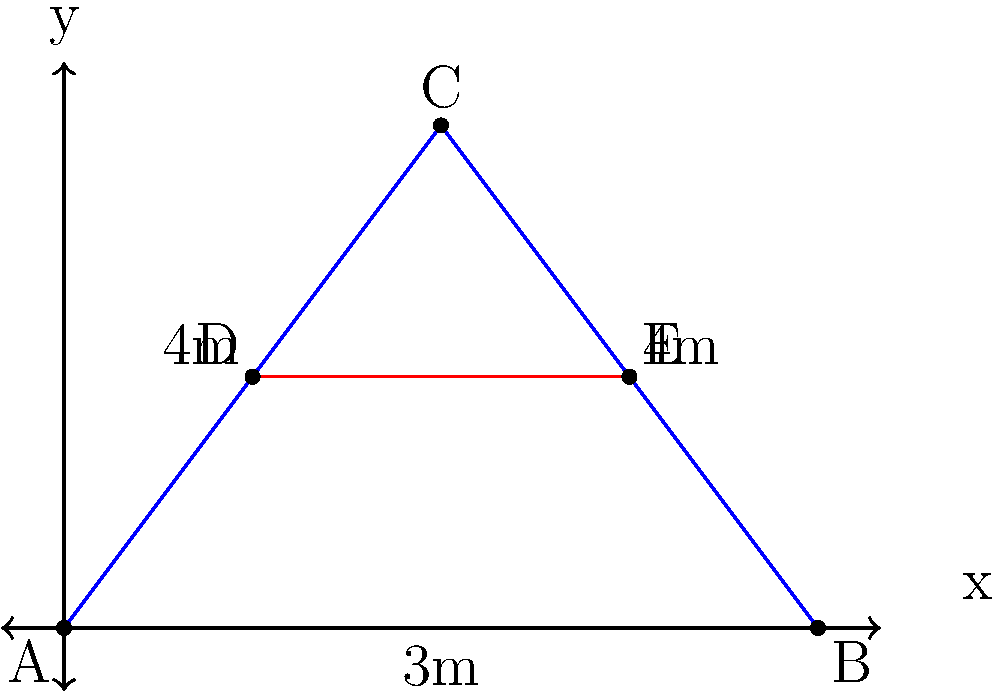Consider the truss bridge shown in the figure. The structure is subjected to a vertical load of 10 kN at point D. Using the method of joints, calculate the force in member CE. Assume the structure is in equilibrium and all joints are pin connections. Express your answer in kN, with tension being positive and compression negative. To solve this problem using the method of joints, we'll follow these steps:

1) First, we need to calculate the reactions at the supports A and B.
   Given the symmetry of the structure and load, we can conclude:
   $R_A = R_B = 5$ kN (upward)

2) We'll start our analysis at joint D, as we know the external force applied there.

3) At joint D:
   $\sum F_y = 0$: $F_{DC} \sin{\theta} - 10 = 0$
   $\sum F_x = 0$: $F_{DE} + F_{DC} \cos{\theta} = 0$

   Where $\theta$ is the angle between DC and the horizontal.
   $\tan{\theta} = \frac{2}{1.5} = \frac{4}{3}$, so $\theta = \arctan{\frac{4}{3}}$

   From the first equation:
   $F_{DC} = \frac{10}{\sin{\theta}} = 10 \sqrt{\frac{25}{16}} = 12.5$ kN (tension)

   From the second equation:
   $F_{DE} = -F_{DC} \cos{\theta} = -12.5 \cdot \frac{3}{5} = -7.5$ kN (compression)

4) Now we can move to joint E:
   $\sum F_y = 0$: $F_{EC} \sin{\theta} = 0$
   $\sum F_x = 0$: $F_{CE} + 7.5 = 0$

   From these, we can directly conclude:
   $F_{EC} = 0$ (zero force member)
   $F_{CE} = -7.5$ kN (compression)

Therefore, the force in member CE is -7.5 kN (compression).
Answer: -7.5 kN 